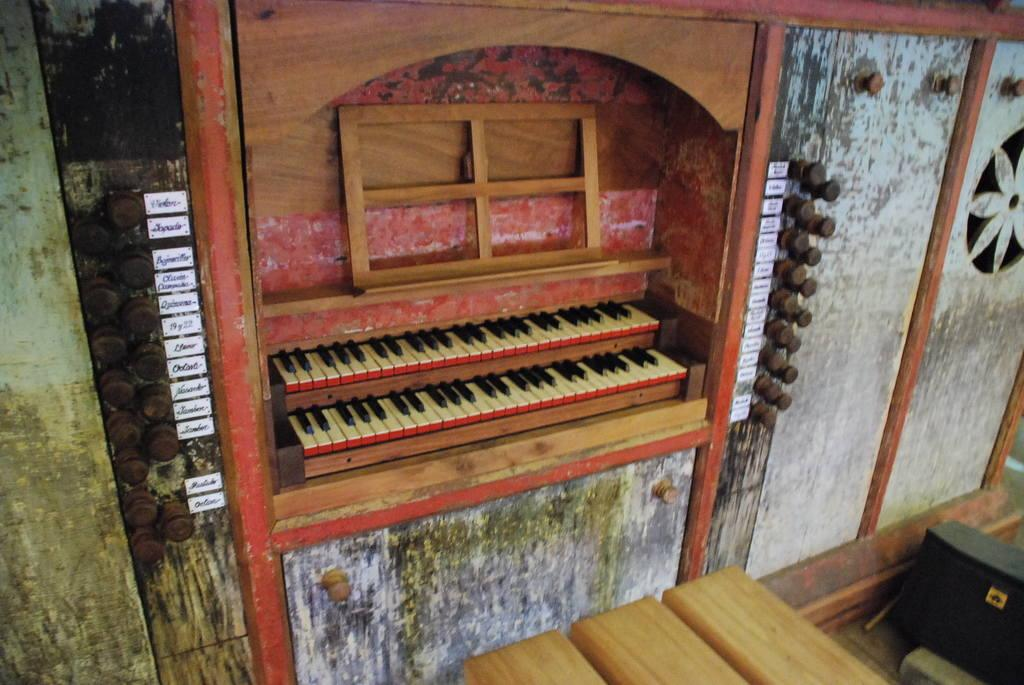What musical instrument is present in the image? There is a piano in the image. What other object can be seen in the image besides the piano? There is a wooden block in the image. What type of observation can be made about the brass elements in the image? There are no brass elements present in the image. 